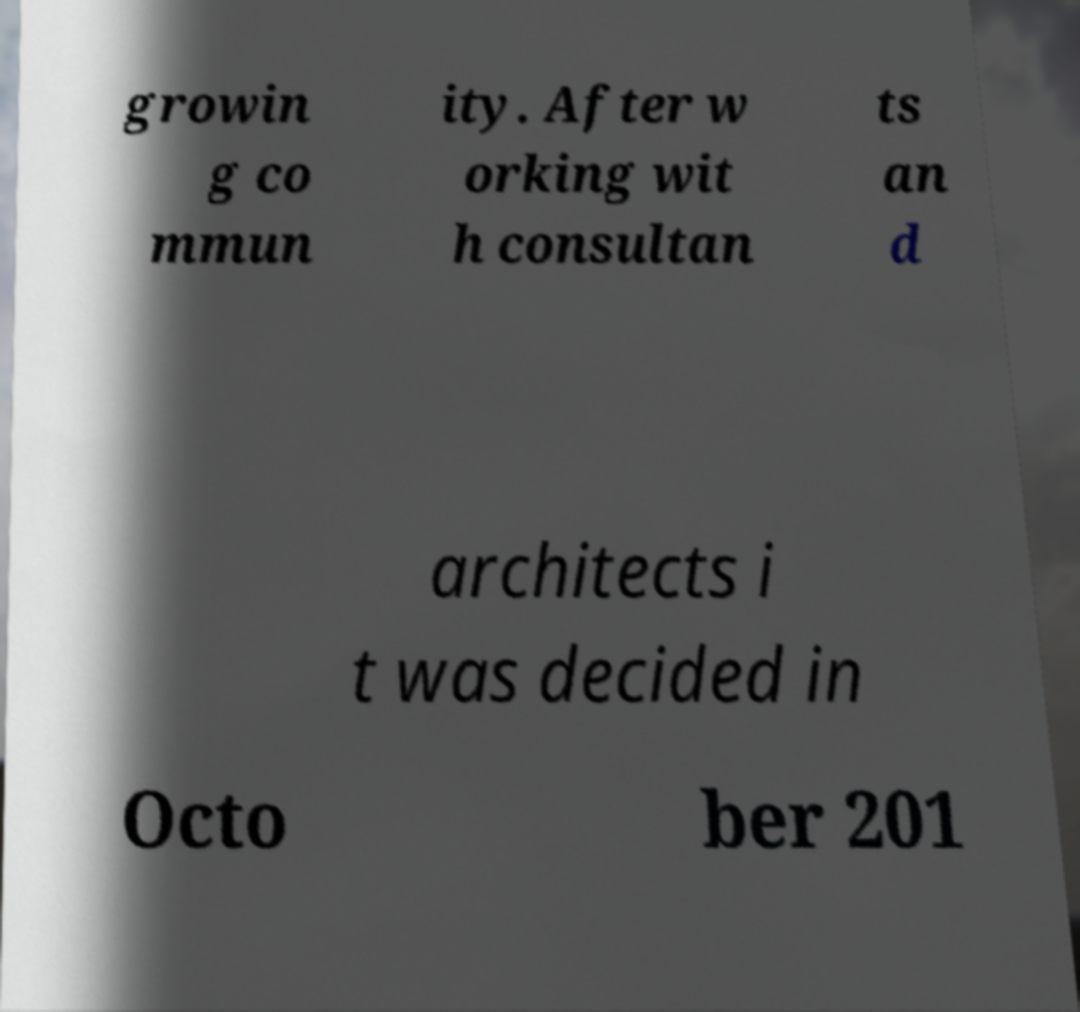What messages or text are displayed in this image? I need them in a readable, typed format. growin g co mmun ity. After w orking wit h consultan ts an d architects i t was decided in Octo ber 201 